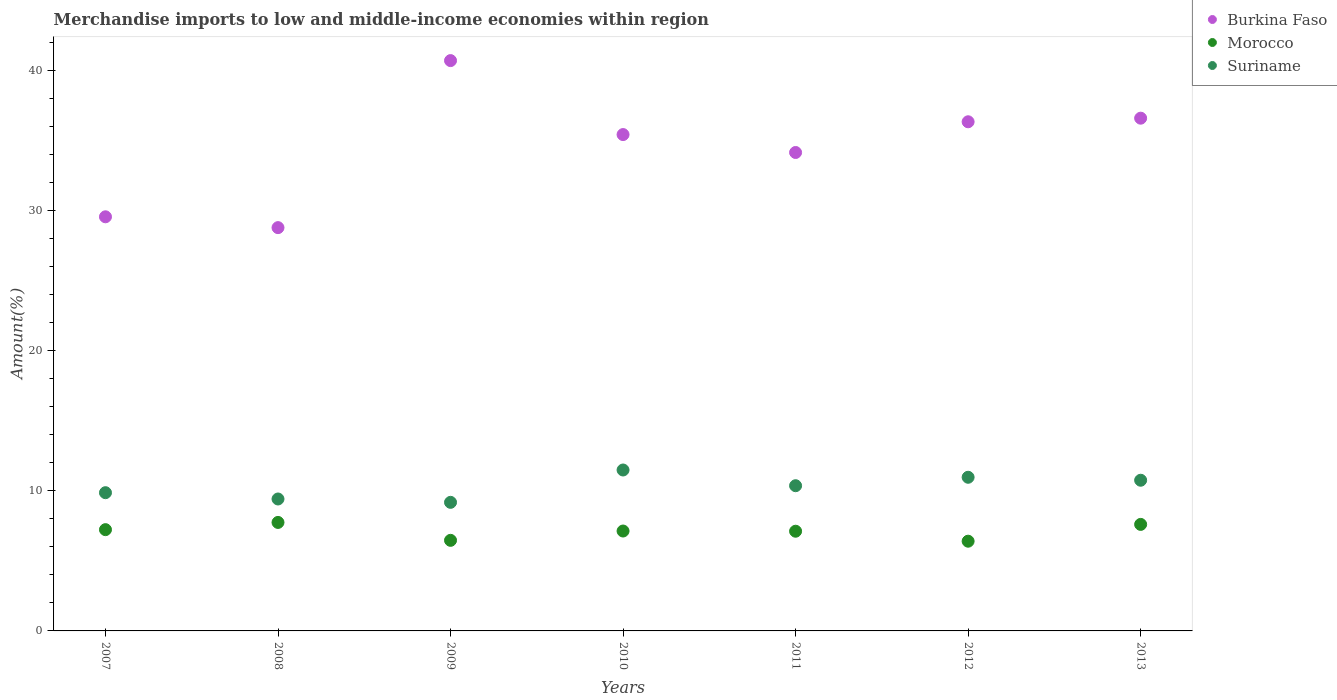Is the number of dotlines equal to the number of legend labels?
Your answer should be very brief. Yes. What is the percentage of amount earned from merchandise imports in Burkina Faso in 2012?
Your response must be concise. 36.31. Across all years, what is the maximum percentage of amount earned from merchandise imports in Burkina Faso?
Your answer should be compact. 40.67. Across all years, what is the minimum percentage of amount earned from merchandise imports in Suriname?
Offer a terse response. 9.17. In which year was the percentage of amount earned from merchandise imports in Burkina Faso maximum?
Your response must be concise. 2009. What is the total percentage of amount earned from merchandise imports in Suriname in the graph?
Ensure brevity in your answer.  71.98. What is the difference between the percentage of amount earned from merchandise imports in Morocco in 2007 and that in 2011?
Offer a very short reply. 0.11. What is the difference between the percentage of amount earned from merchandise imports in Morocco in 2011 and the percentage of amount earned from merchandise imports in Suriname in 2012?
Give a very brief answer. -3.85. What is the average percentage of amount earned from merchandise imports in Suriname per year?
Offer a terse response. 10.28. In the year 2007, what is the difference between the percentage of amount earned from merchandise imports in Suriname and percentage of amount earned from merchandise imports in Burkina Faso?
Your answer should be very brief. -19.68. What is the ratio of the percentage of amount earned from merchandise imports in Suriname in 2008 to that in 2010?
Give a very brief answer. 0.82. Is the percentage of amount earned from merchandise imports in Burkina Faso in 2009 less than that in 2012?
Offer a terse response. No. What is the difference between the highest and the second highest percentage of amount earned from merchandise imports in Morocco?
Offer a very short reply. 0.14. What is the difference between the highest and the lowest percentage of amount earned from merchandise imports in Morocco?
Offer a very short reply. 1.34. Is the sum of the percentage of amount earned from merchandise imports in Burkina Faso in 2009 and 2010 greater than the maximum percentage of amount earned from merchandise imports in Morocco across all years?
Offer a terse response. Yes. Is it the case that in every year, the sum of the percentage of amount earned from merchandise imports in Morocco and percentage of amount earned from merchandise imports in Burkina Faso  is greater than the percentage of amount earned from merchandise imports in Suriname?
Ensure brevity in your answer.  Yes. Is the percentage of amount earned from merchandise imports in Suriname strictly greater than the percentage of amount earned from merchandise imports in Burkina Faso over the years?
Give a very brief answer. No. Is the percentage of amount earned from merchandise imports in Morocco strictly less than the percentage of amount earned from merchandise imports in Burkina Faso over the years?
Ensure brevity in your answer.  Yes. How many dotlines are there?
Offer a very short reply. 3. How many years are there in the graph?
Make the answer very short. 7. What is the difference between two consecutive major ticks on the Y-axis?
Ensure brevity in your answer.  10. Does the graph contain grids?
Your response must be concise. No. What is the title of the graph?
Your answer should be compact. Merchandise imports to low and middle-income economies within region. What is the label or title of the X-axis?
Your answer should be compact. Years. What is the label or title of the Y-axis?
Your answer should be very brief. Amount(%). What is the Amount(%) in Burkina Faso in 2007?
Your answer should be compact. 29.53. What is the Amount(%) of Morocco in 2007?
Offer a terse response. 7.22. What is the Amount(%) in Suriname in 2007?
Your response must be concise. 9.86. What is the Amount(%) of Burkina Faso in 2008?
Keep it short and to the point. 28.76. What is the Amount(%) of Morocco in 2008?
Provide a short and direct response. 7.74. What is the Amount(%) of Suriname in 2008?
Give a very brief answer. 9.41. What is the Amount(%) in Burkina Faso in 2009?
Your answer should be very brief. 40.67. What is the Amount(%) in Morocco in 2009?
Offer a terse response. 6.46. What is the Amount(%) of Suriname in 2009?
Give a very brief answer. 9.17. What is the Amount(%) of Burkina Faso in 2010?
Offer a terse response. 35.4. What is the Amount(%) of Morocco in 2010?
Your response must be concise. 7.12. What is the Amount(%) of Suriname in 2010?
Your answer should be compact. 11.48. What is the Amount(%) in Burkina Faso in 2011?
Ensure brevity in your answer.  34.12. What is the Amount(%) in Morocco in 2011?
Give a very brief answer. 7.11. What is the Amount(%) of Suriname in 2011?
Keep it short and to the point. 10.36. What is the Amount(%) in Burkina Faso in 2012?
Your answer should be compact. 36.31. What is the Amount(%) in Morocco in 2012?
Your response must be concise. 6.4. What is the Amount(%) of Suriname in 2012?
Ensure brevity in your answer.  10.96. What is the Amount(%) in Burkina Faso in 2013?
Your answer should be very brief. 36.57. What is the Amount(%) of Morocco in 2013?
Provide a short and direct response. 7.6. What is the Amount(%) in Suriname in 2013?
Your response must be concise. 10.75. Across all years, what is the maximum Amount(%) in Burkina Faso?
Ensure brevity in your answer.  40.67. Across all years, what is the maximum Amount(%) in Morocco?
Give a very brief answer. 7.74. Across all years, what is the maximum Amount(%) in Suriname?
Ensure brevity in your answer.  11.48. Across all years, what is the minimum Amount(%) of Burkina Faso?
Ensure brevity in your answer.  28.76. Across all years, what is the minimum Amount(%) of Morocco?
Offer a very short reply. 6.4. Across all years, what is the minimum Amount(%) in Suriname?
Provide a succinct answer. 9.17. What is the total Amount(%) of Burkina Faso in the graph?
Give a very brief answer. 241.37. What is the total Amount(%) of Morocco in the graph?
Your answer should be very brief. 49.65. What is the total Amount(%) of Suriname in the graph?
Offer a very short reply. 71.98. What is the difference between the Amount(%) in Burkina Faso in 2007 and that in 2008?
Offer a terse response. 0.77. What is the difference between the Amount(%) in Morocco in 2007 and that in 2008?
Make the answer very short. -0.51. What is the difference between the Amount(%) of Suriname in 2007 and that in 2008?
Provide a succinct answer. 0.45. What is the difference between the Amount(%) in Burkina Faso in 2007 and that in 2009?
Give a very brief answer. -11.14. What is the difference between the Amount(%) in Morocco in 2007 and that in 2009?
Provide a succinct answer. 0.76. What is the difference between the Amount(%) in Suriname in 2007 and that in 2009?
Give a very brief answer. 0.69. What is the difference between the Amount(%) of Burkina Faso in 2007 and that in 2010?
Offer a terse response. -5.86. What is the difference between the Amount(%) of Morocco in 2007 and that in 2010?
Provide a succinct answer. 0.1. What is the difference between the Amount(%) of Suriname in 2007 and that in 2010?
Offer a very short reply. -1.62. What is the difference between the Amount(%) of Burkina Faso in 2007 and that in 2011?
Provide a short and direct response. -4.59. What is the difference between the Amount(%) in Morocco in 2007 and that in 2011?
Your answer should be very brief. 0.11. What is the difference between the Amount(%) of Suriname in 2007 and that in 2011?
Your answer should be very brief. -0.5. What is the difference between the Amount(%) in Burkina Faso in 2007 and that in 2012?
Give a very brief answer. -6.78. What is the difference between the Amount(%) in Morocco in 2007 and that in 2012?
Provide a short and direct response. 0.82. What is the difference between the Amount(%) in Suriname in 2007 and that in 2012?
Your answer should be compact. -1.1. What is the difference between the Amount(%) of Burkina Faso in 2007 and that in 2013?
Offer a very short reply. -7.03. What is the difference between the Amount(%) in Morocco in 2007 and that in 2013?
Provide a short and direct response. -0.38. What is the difference between the Amount(%) in Suriname in 2007 and that in 2013?
Provide a succinct answer. -0.89. What is the difference between the Amount(%) of Burkina Faso in 2008 and that in 2009?
Ensure brevity in your answer.  -11.91. What is the difference between the Amount(%) in Morocco in 2008 and that in 2009?
Your response must be concise. 1.28. What is the difference between the Amount(%) of Suriname in 2008 and that in 2009?
Your answer should be compact. 0.24. What is the difference between the Amount(%) of Burkina Faso in 2008 and that in 2010?
Your response must be concise. -6.64. What is the difference between the Amount(%) in Morocco in 2008 and that in 2010?
Offer a terse response. 0.61. What is the difference between the Amount(%) in Suriname in 2008 and that in 2010?
Ensure brevity in your answer.  -2.07. What is the difference between the Amount(%) in Burkina Faso in 2008 and that in 2011?
Offer a very short reply. -5.36. What is the difference between the Amount(%) of Morocco in 2008 and that in 2011?
Give a very brief answer. 0.63. What is the difference between the Amount(%) of Suriname in 2008 and that in 2011?
Your response must be concise. -0.95. What is the difference between the Amount(%) in Burkina Faso in 2008 and that in 2012?
Ensure brevity in your answer.  -7.55. What is the difference between the Amount(%) of Morocco in 2008 and that in 2012?
Ensure brevity in your answer.  1.34. What is the difference between the Amount(%) of Suriname in 2008 and that in 2012?
Offer a very short reply. -1.55. What is the difference between the Amount(%) of Burkina Faso in 2008 and that in 2013?
Your answer should be compact. -7.81. What is the difference between the Amount(%) of Morocco in 2008 and that in 2013?
Offer a very short reply. 0.14. What is the difference between the Amount(%) in Suriname in 2008 and that in 2013?
Provide a short and direct response. -1.34. What is the difference between the Amount(%) in Burkina Faso in 2009 and that in 2010?
Provide a short and direct response. 5.28. What is the difference between the Amount(%) of Morocco in 2009 and that in 2010?
Ensure brevity in your answer.  -0.66. What is the difference between the Amount(%) of Suriname in 2009 and that in 2010?
Make the answer very short. -2.31. What is the difference between the Amount(%) of Burkina Faso in 2009 and that in 2011?
Offer a terse response. 6.55. What is the difference between the Amount(%) of Morocco in 2009 and that in 2011?
Provide a succinct answer. -0.65. What is the difference between the Amount(%) in Suriname in 2009 and that in 2011?
Offer a very short reply. -1.19. What is the difference between the Amount(%) in Burkina Faso in 2009 and that in 2012?
Give a very brief answer. 4.36. What is the difference between the Amount(%) in Morocco in 2009 and that in 2012?
Keep it short and to the point. 0.06. What is the difference between the Amount(%) in Suriname in 2009 and that in 2012?
Provide a succinct answer. -1.79. What is the difference between the Amount(%) in Burkina Faso in 2009 and that in 2013?
Provide a succinct answer. 4.11. What is the difference between the Amount(%) of Morocco in 2009 and that in 2013?
Make the answer very short. -1.14. What is the difference between the Amount(%) in Suriname in 2009 and that in 2013?
Offer a terse response. -1.58. What is the difference between the Amount(%) in Burkina Faso in 2010 and that in 2011?
Ensure brevity in your answer.  1.28. What is the difference between the Amount(%) of Morocco in 2010 and that in 2011?
Ensure brevity in your answer.  0.01. What is the difference between the Amount(%) in Suriname in 2010 and that in 2011?
Offer a terse response. 1.12. What is the difference between the Amount(%) in Burkina Faso in 2010 and that in 2012?
Your answer should be very brief. -0.91. What is the difference between the Amount(%) in Morocco in 2010 and that in 2012?
Ensure brevity in your answer.  0.73. What is the difference between the Amount(%) of Suriname in 2010 and that in 2012?
Offer a terse response. 0.52. What is the difference between the Amount(%) in Burkina Faso in 2010 and that in 2013?
Make the answer very short. -1.17. What is the difference between the Amount(%) of Morocco in 2010 and that in 2013?
Provide a succinct answer. -0.47. What is the difference between the Amount(%) of Suriname in 2010 and that in 2013?
Keep it short and to the point. 0.73. What is the difference between the Amount(%) of Burkina Faso in 2011 and that in 2012?
Provide a short and direct response. -2.19. What is the difference between the Amount(%) in Morocco in 2011 and that in 2012?
Make the answer very short. 0.71. What is the difference between the Amount(%) in Suriname in 2011 and that in 2012?
Provide a short and direct response. -0.6. What is the difference between the Amount(%) in Burkina Faso in 2011 and that in 2013?
Provide a short and direct response. -2.45. What is the difference between the Amount(%) in Morocco in 2011 and that in 2013?
Make the answer very short. -0.49. What is the difference between the Amount(%) in Suriname in 2011 and that in 2013?
Keep it short and to the point. -0.39. What is the difference between the Amount(%) of Burkina Faso in 2012 and that in 2013?
Your response must be concise. -0.26. What is the difference between the Amount(%) of Morocco in 2012 and that in 2013?
Offer a very short reply. -1.2. What is the difference between the Amount(%) of Suriname in 2012 and that in 2013?
Keep it short and to the point. 0.21. What is the difference between the Amount(%) of Burkina Faso in 2007 and the Amount(%) of Morocco in 2008?
Offer a very short reply. 21.8. What is the difference between the Amount(%) of Burkina Faso in 2007 and the Amount(%) of Suriname in 2008?
Your answer should be compact. 20.13. What is the difference between the Amount(%) of Morocco in 2007 and the Amount(%) of Suriname in 2008?
Provide a succinct answer. -2.19. What is the difference between the Amount(%) of Burkina Faso in 2007 and the Amount(%) of Morocco in 2009?
Your answer should be compact. 23.07. What is the difference between the Amount(%) in Burkina Faso in 2007 and the Amount(%) in Suriname in 2009?
Your answer should be compact. 20.36. What is the difference between the Amount(%) of Morocco in 2007 and the Amount(%) of Suriname in 2009?
Provide a succinct answer. -1.95. What is the difference between the Amount(%) in Burkina Faso in 2007 and the Amount(%) in Morocco in 2010?
Provide a short and direct response. 22.41. What is the difference between the Amount(%) of Burkina Faso in 2007 and the Amount(%) of Suriname in 2010?
Your answer should be very brief. 18.06. What is the difference between the Amount(%) in Morocco in 2007 and the Amount(%) in Suriname in 2010?
Your answer should be compact. -4.25. What is the difference between the Amount(%) in Burkina Faso in 2007 and the Amount(%) in Morocco in 2011?
Offer a very short reply. 22.42. What is the difference between the Amount(%) of Burkina Faso in 2007 and the Amount(%) of Suriname in 2011?
Your answer should be compact. 19.18. What is the difference between the Amount(%) of Morocco in 2007 and the Amount(%) of Suriname in 2011?
Provide a short and direct response. -3.13. What is the difference between the Amount(%) of Burkina Faso in 2007 and the Amount(%) of Morocco in 2012?
Your answer should be very brief. 23.14. What is the difference between the Amount(%) in Burkina Faso in 2007 and the Amount(%) in Suriname in 2012?
Give a very brief answer. 18.58. What is the difference between the Amount(%) in Morocco in 2007 and the Amount(%) in Suriname in 2012?
Your response must be concise. -3.74. What is the difference between the Amount(%) of Burkina Faso in 2007 and the Amount(%) of Morocco in 2013?
Make the answer very short. 21.94. What is the difference between the Amount(%) in Burkina Faso in 2007 and the Amount(%) in Suriname in 2013?
Your answer should be very brief. 18.79. What is the difference between the Amount(%) in Morocco in 2007 and the Amount(%) in Suriname in 2013?
Provide a short and direct response. -3.52. What is the difference between the Amount(%) in Burkina Faso in 2008 and the Amount(%) in Morocco in 2009?
Your answer should be very brief. 22.3. What is the difference between the Amount(%) of Burkina Faso in 2008 and the Amount(%) of Suriname in 2009?
Your answer should be compact. 19.59. What is the difference between the Amount(%) in Morocco in 2008 and the Amount(%) in Suriname in 2009?
Your answer should be compact. -1.43. What is the difference between the Amount(%) of Burkina Faso in 2008 and the Amount(%) of Morocco in 2010?
Your answer should be compact. 21.64. What is the difference between the Amount(%) of Burkina Faso in 2008 and the Amount(%) of Suriname in 2010?
Provide a short and direct response. 17.29. What is the difference between the Amount(%) in Morocco in 2008 and the Amount(%) in Suriname in 2010?
Offer a terse response. -3.74. What is the difference between the Amount(%) in Burkina Faso in 2008 and the Amount(%) in Morocco in 2011?
Your answer should be very brief. 21.65. What is the difference between the Amount(%) in Burkina Faso in 2008 and the Amount(%) in Suriname in 2011?
Offer a very short reply. 18.41. What is the difference between the Amount(%) of Morocco in 2008 and the Amount(%) of Suriname in 2011?
Provide a short and direct response. -2.62. What is the difference between the Amount(%) in Burkina Faso in 2008 and the Amount(%) in Morocco in 2012?
Your answer should be compact. 22.36. What is the difference between the Amount(%) in Burkina Faso in 2008 and the Amount(%) in Suriname in 2012?
Provide a succinct answer. 17.8. What is the difference between the Amount(%) of Morocco in 2008 and the Amount(%) of Suriname in 2012?
Your response must be concise. -3.22. What is the difference between the Amount(%) in Burkina Faso in 2008 and the Amount(%) in Morocco in 2013?
Your response must be concise. 21.16. What is the difference between the Amount(%) in Burkina Faso in 2008 and the Amount(%) in Suriname in 2013?
Your response must be concise. 18.02. What is the difference between the Amount(%) in Morocco in 2008 and the Amount(%) in Suriname in 2013?
Provide a short and direct response. -3.01. What is the difference between the Amount(%) in Burkina Faso in 2009 and the Amount(%) in Morocco in 2010?
Your answer should be compact. 33.55. What is the difference between the Amount(%) of Burkina Faso in 2009 and the Amount(%) of Suriname in 2010?
Keep it short and to the point. 29.2. What is the difference between the Amount(%) of Morocco in 2009 and the Amount(%) of Suriname in 2010?
Offer a terse response. -5.02. What is the difference between the Amount(%) in Burkina Faso in 2009 and the Amount(%) in Morocco in 2011?
Your answer should be compact. 33.56. What is the difference between the Amount(%) in Burkina Faso in 2009 and the Amount(%) in Suriname in 2011?
Keep it short and to the point. 30.32. What is the difference between the Amount(%) of Morocco in 2009 and the Amount(%) of Suriname in 2011?
Keep it short and to the point. -3.9. What is the difference between the Amount(%) of Burkina Faso in 2009 and the Amount(%) of Morocco in 2012?
Offer a very short reply. 34.28. What is the difference between the Amount(%) of Burkina Faso in 2009 and the Amount(%) of Suriname in 2012?
Give a very brief answer. 29.72. What is the difference between the Amount(%) in Morocco in 2009 and the Amount(%) in Suriname in 2012?
Provide a short and direct response. -4.5. What is the difference between the Amount(%) of Burkina Faso in 2009 and the Amount(%) of Morocco in 2013?
Provide a succinct answer. 33.08. What is the difference between the Amount(%) in Burkina Faso in 2009 and the Amount(%) in Suriname in 2013?
Your answer should be very brief. 29.93. What is the difference between the Amount(%) of Morocco in 2009 and the Amount(%) of Suriname in 2013?
Provide a short and direct response. -4.29. What is the difference between the Amount(%) in Burkina Faso in 2010 and the Amount(%) in Morocco in 2011?
Keep it short and to the point. 28.29. What is the difference between the Amount(%) in Burkina Faso in 2010 and the Amount(%) in Suriname in 2011?
Ensure brevity in your answer.  25.04. What is the difference between the Amount(%) in Morocco in 2010 and the Amount(%) in Suriname in 2011?
Your answer should be very brief. -3.23. What is the difference between the Amount(%) in Burkina Faso in 2010 and the Amount(%) in Morocco in 2012?
Ensure brevity in your answer.  29. What is the difference between the Amount(%) in Burkina Faso in 2010 and the Amount(%) in Suriname in 2012?
Provide a short and direct response. 24.44. What is the difference between the Amount(%) of Morocco in 2010 and the Amount(%) of Suriname in 2012?
Offer a terse response. -3.83. What is the difference between the Amount(%) in Burkina Faso in 2010 and the Amount(%) in Morocco in 2013?
Your answer should be very brief. 27.8. What is the difference between the Amount(%) of Burkina Faso in 2010 and the Amount(%) of Suriname in 2013?
Your answer should be compact. 24.65. What is the difference between the Amount(%) in Morocco in 2010 and the Amount(%) in Suriname in 2013?
Your answer should be compact. -3.62. What is the difference between the Amount(%) of Burkina Faso in 2011 and the Amount(%) of Morocco in 2012?
Your response must be concise. 27.72. What is the difference between the Amount(%) of Burkina Faso in 2011 and the Amount(%) of Suriname in 2012?
Ensure brevity in your answer.  23.16. What is the difference between the Amount(%) of Morocco in 2011 and the Amount(%) of Suriname in 2012?
Ensure brevity in your answer.  -3.85. What is the difference between the Amount(%) of Burkina Faso in 2011 and the Amount(%) of Morocco in 2013?
Your answer should be very brief. 26.52. What is the difference between the Amount(%) in Burkina Faso in 2011 and the Amount(%) in Suriname in 2013?
Give a very brief answer. 23.37. What is the difference between the Amount(%) of Morocco in 2011 and the Amount(%) of Suriname in 2013?
Offer a very short reply. -3.64. What is the difference between the Amount(%) of Burkina Faso in 2012 and the Amount(%) of Morocco in 2013?
Your answer should be very brief. 28.71. What is the difference between the Amount(%) of Burkina Faso in 2012 and the Amount(%) of Suriname in 2013?
Keep it short and to the point. 25.56. What is the difference between the Amount(%) in Morocco in 2012 and the Amount(%) in Suriname in 2013?
Give a very brief answer. -4.35. What is the average Amount(%) of Burkina Faso per year?
Your answer should be compact. 34.48. What is the average Amount(%) in Morocco per year?
Offer a terse response. 7.09. What is the average Amount(%) in Suriname per year?
Ensure brevity in your answer.  10.28. In the year 2007, what is the difference between the Amount(%) of Burkina Faso and Amount(%) of Morocco?
Provide a short and direct response. 22.31. In the year 2007, what is the difference between the Amount(%) of Burkina Faso and Amount(%) of Suriname?
Provide a short and direct response. 19.68. In the year 2007, what is the difference between the Amount(%) of Morocco and Amount(%) of Suriname?
Your answer should be compact. -2.64. In the year 2008, what is the difference between the Amount(%) in Burkina Faso and Amount(%) in Morocco?
Your response must be concise. 21.02. In the year 2008, what is the difference between the Amount(%) in Burkina Faso and Amount(%) in Suriname?
Ensure brevity in your answer.  19.35. In the year 2008, what is the difference between the Amount(%) of Morocco and Amount(%) of Suriname?
Provide a short and direct response. -1.67. In the year 2009, what is the difference between the Amount(%) of Burkina Faso and Amount(%) of Morocco?
Your answer should be compact. 34.21. In the year 2009, what is the difference between the Amount(%) of Burkina Faso and Amount(%) of Suriname?
Make the answer very short. 31.5. In the year 2009, what is the difference between the Amount(%) of Morocco and Amount(%) of Suriname?
Offer a very short reply. -2.71. In the year 2010, what is the difference between the Amount(%) of Burkina Faso and Amount(%) of Morocco?
Provide a succinct answer. 28.27. In the year 2010, what is the difference between the Amount(%) of Burkina Faso and Amount(%) of Suriname?
Offer a terse response. 23.92. In the year 2010, what is the difference between the Amount(%) in Morocco and Amount(%) in Suriname?
Provide a succinct answer. -4.35. In the year 2011, what is the difference between the Amount(%) in Burkina Faso and Amount(%) in Morocco?
Make the answer very short. 27.01. In the year 2011, what is the difference between the Amount(%) of Burkina Faso and Amount(%) of Suriname?
Provide a short and direct response. 23.77. In the year 2011, what is the difference between the Amount(%) of Morocco and Amount(%) of Suriname?
Your answer should be compact. -3.25. In the year 2012, what is the difference between the Amount(%) in Burkina Faso and Amount(%) in Morocco?
Make the answer very short. 29.91. In the year 2012, what is the difference between the Amount(%) of Burkina Faso and Amount(%) of Suriname?
Keep it short and to the point. 25.35. In the year 2012, what is the difference between the Amount(%) in Morocco and Amount(%) in Suriname?
Offer a terse response. -4.56. In the year 2013, what is the difference between the Amount(%) of Burkina Faso and Amount(%) of Morocco?
Your response must be concise. 28.97. In the year 2013, what is the difference between the Amount(%) of Burkina Faso and Amount(%) of Suriname?
Keep it short and to the point. 25.82. In the year 2013, what is the difference between the Amount(%) of Morocco and Amount(%) of Suriname?
Provide a short and direct response. -3.15. What is the ratio of the Amount(%) in Burkina Faso in 2007 to that in 2008?
Your answer should be very brief. 1.03. What is the ratio of the Amount(%) of Morocco in 2007 to that in 2008?
Your response must be concise. 0.93. What is the ratio of the Amount(%) in Suriname in 2007 to that in 2008?
Your answer should be very brief. 1.05. What is the ratio of the Amount(%) in Burkina Faso in 2007 to that in 2009?
Your response must be concise. 0.73. What is the ratio of the Amount(%) of Morocco in 2007 to that in 2009?
Keep it short and to the point. 1.12. What is the ratio of the Amount(%) of Suriname in 2007 to that in 2009?
Offer a very short reply. 1.08. What is the ratio of the Amount(%) of Burkina Faso in 2007 to that in 2010?
Your response must be concise. 0.83. What is the ratio of the Amount(%) of Morocco in 2007 to that in 2010?
Your response must be concise. 1.01. What is the ratio of the Amount(%) in Suriname in 2007 to that in 2010?
Your answer should be very brief. 0.86. What is the ratio of the Amount(%) in Burkina Faso in 2007 to that in 2011?
Your answer should be very brief. 0.87. What is the ratio of the Amount(%) of Morocco in 2007 to that in 2011?
Give a very brief answer. 1.02. What is the ratio of the Amount(%) of Burkina Faso in 2007 to that in 2012?
Your response must be concise. 0.81. What is the ratio of the Amount(%) in Morocco in 2007 to that in 2012?
Give a very brief answer. 1.13. What is the ratio of the Amount(%) in Suriname in 2007 to that in 2012?
Provide a succinct answer. 0.9. What is the ratio of the Amount(%) of Burkina Faso in 2007 to that in 2013?
Provide a short and direct response. 0.81. What is the ratio of the Amount(%) in Morocco in 2007 to that in 2013?
Ensure brevity in your answer.  0.95. What is the ratio of the Amount(%) of Suriname in 2007 to that in 2013?
Offer a terse response. 0.92. What is the ratio of the Amount(%) of Burkina Faso in 2008 to that in 2009?
Ensure brevity in your answer.  0.71. What is the ratio of the Amount(%) of Morocco in 2008 to that in 2009?
Your answer should be very brief. 1.2. What is the ratio of the Amount(%) in Suriname in 2008 to that in 2009?
Offer a terse response. 1.03. What is the ratio of the Amount(%) of Burkina Faso in 2008 to that in 2010?
Provide a short and direct response. 0.81. What is the ratio of the Amount(%) of Morocco in 2008 to that in 2010?
Provide a succinct answer. 1.09. What is the ratio of the Amount(%) in Suriname in 2008 to that in 2010?
Your answer should be very brief. 0.82. What is the ratio of the Amount(%) of Burkina Faso in 2008 to that in 2011?
Provide a short and direct response. 0.84. What is the ratio of the Amount(%) in Morocco in 2008 to that in 2011?
Make the answer very short. 1.09. What is the ratio of the Amount(%) of Suriname in 2008 to that in 2011?
Ensure brevity in your answer.  0.91. What is the ratio of the Amount(%) of Burkina Faso in 2008 to that in 2012?
Ensure brevity in your answer.  0.79. What is the ratio of the Amount(%) of Morocco in 2008 to that in 2012?
Provide a short and direct response. 1.21. What is the ratio of the Amount(%) in Suriname in 2008 to that in 2012?
Make the answer very short. 0.86. What is the ratio of the Amount(%) of Burkina Faso in 2008 to that in 2013?
Your answer should be very brief. 0.79. What is the ratio of the Amount(%) of Morocco in 2008 to that in 2013?
Ensure brevity in your answer.  1.02. What is the ratio of the Amount(%) in Suriname in 2008 to that in 2013?
Keep it short and to the point. 0.88. What is the ratio of the Amount(%) in Burkina Faso in 2009 to that in 2010?
Ensure brevity in your answer.  1.15. What is the ratio of the Amount(%) in Morocco in 2009 to that in 2010?
Ensure brevity in your answer.  0.91. What is the ratio of the Amount(%) of Suriname in 2009 to that in 2010?
Offer a very short reply. 0.8. What is the ratio of the Amount(%) of Burkina Faso in 2009 to that in 2011?
Your response must be concise. 1.19. What is the ratio of the Amount(%) of Morocco in 2009 to that in 2011?
Keep it short and to the point. 0.91. What is the ratio of the Amount(%) of Suriname in 2009 to that in 2011?
Your response must be concise. 0.89. What is the ratio of the Amount(%) of Burkina Faso in 2009 to that in 2012?
Keep it short and to the point. 1.12. What is the ratio of the Amount(%) in Morocco in 2009 to that in 2012?
Provide a short and direct response. 1.01. What is the ratio of the Amount(%) in Suriname in 2009 to that in 2012?
Make the answer very short. 0.84. What is the ratio of the Amount(%) in Burkina Faso in 2009 to that in 2013?
Offer a very short reply. 1.11. What is the ratio of the Amount(%) of Morocco in 2009 to that in 2013?
Your answer should be compact. 0.85. What is the ratio of the Amount(%) of Suriname in 2009 to that in 2013?
Make the answer very short. 0.85. What is the ratio of the Amount(%) of Burkina Faso in 2010 to that in 2011?
Keep it short and to the point. 1.04. What is the ratio of the Amount(%) of Morocco in 2010 to that in 2011?
Your answer should be very brief. 1. What is the ratio of the Amount(%) in Suriname in 2010 to that in 2011?
Ensure brevity in your answer.  1.11. What is the ratio of the Amount(%) in Burkina Faso in 2010 to that in 2012?
Provide a short and direct response. 0.97. What is the ratio of the Amount(%) of Morocco in 2010 to that in 2012?
Your answer should be very brief. 1.11. What is the ratio of the Amount(%) in Suriname in 2010 to that in 2012?
Ensure brevity in your answer.  1.05. What is the ratio of the Amount(%) in Morocco in 2010 to that in 2013?
Give a very brief answer. 0.94. What is the ratio of the Amount(%) of Suriname in 2010 to that in 2013?
Your answer should be compact. 1.07. What is the ratio of the Amount(%) in Burkina Faso in 2011 to that in 2012?
Your answer should be very brief. 0.94. What is the ratio of the Amount(%) in Morocco in 2011 to that in 2012?
Make the answer very short. 1.11. What is the ratio of the Amount(%) in Suriname in 2011 to that in 2012?
Give a very brief answer. 0.94. What is the ratio of the Amount(%) of Burkina Faso in 2011 to that in 2013?
Give a very brief answer. 0.93. What is the ratio of the Amount(%) in Morocco in 2011 to that in 2013?
Provide a short and direct response. 0.94. What is the ratio of the Amount(%) of Suriname in 2011 to that in 2013?
Provide a short and direct response. 0.96. What is the ratio of the Amount(%) of Morocco in 2012 to that in 2013?
Make the answer very short. 0.84. What is the ratio of the Amount(%) of Suriname in 2012 to that in 2013?
Your answer should be compact. 1.02. What is the difference between the highest and the second highest Amount(%) in Burkina Faso?
Give a very brief answer. 4.11. What is the difference between the highest and the second highest Amount(%) in Morocco?
Your answer should be very brief. 0.14. What is the difference between the highest and the second highest Amount(%) in Suriname?
Provide a succinct answer. 0.52. What is the difference between the highest and the lowest Amount(%) in Burkina Faso?
Your answer should be compact. 11.91. What is the difference between the highest and the lowest Amount(%) in Morocco?
Offer a terse response. 1.34. What is the difference between the highest and the lowest Amount(%) in Suriname?
Ensure brevity in your answer.  2.31. 